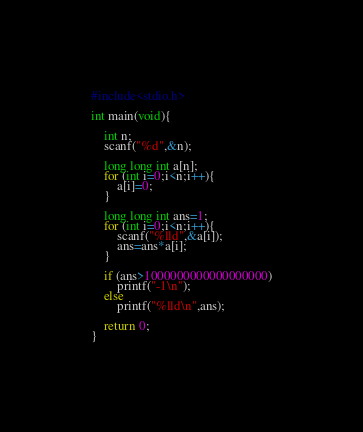<code> <loc_0><loc_0><loc_500><loc_500><_C_>#include<stdio.h>

int main(void){

    int n;
    scanf("%d",&n);

    long long int a[n];
    for (int i=0;i<n;i++){
        a[i]=0;
    }

    long long int ans=1;
    for (int i=0;i<n;i++){
        scanf("%lld",&a[i]);
        ans=ans*a[i];
    }

    if (ans>1000000000000000000)
        printf("-1\n");
    else
        printf("%lld\n",ans);
    
    return 0;
}</code> 